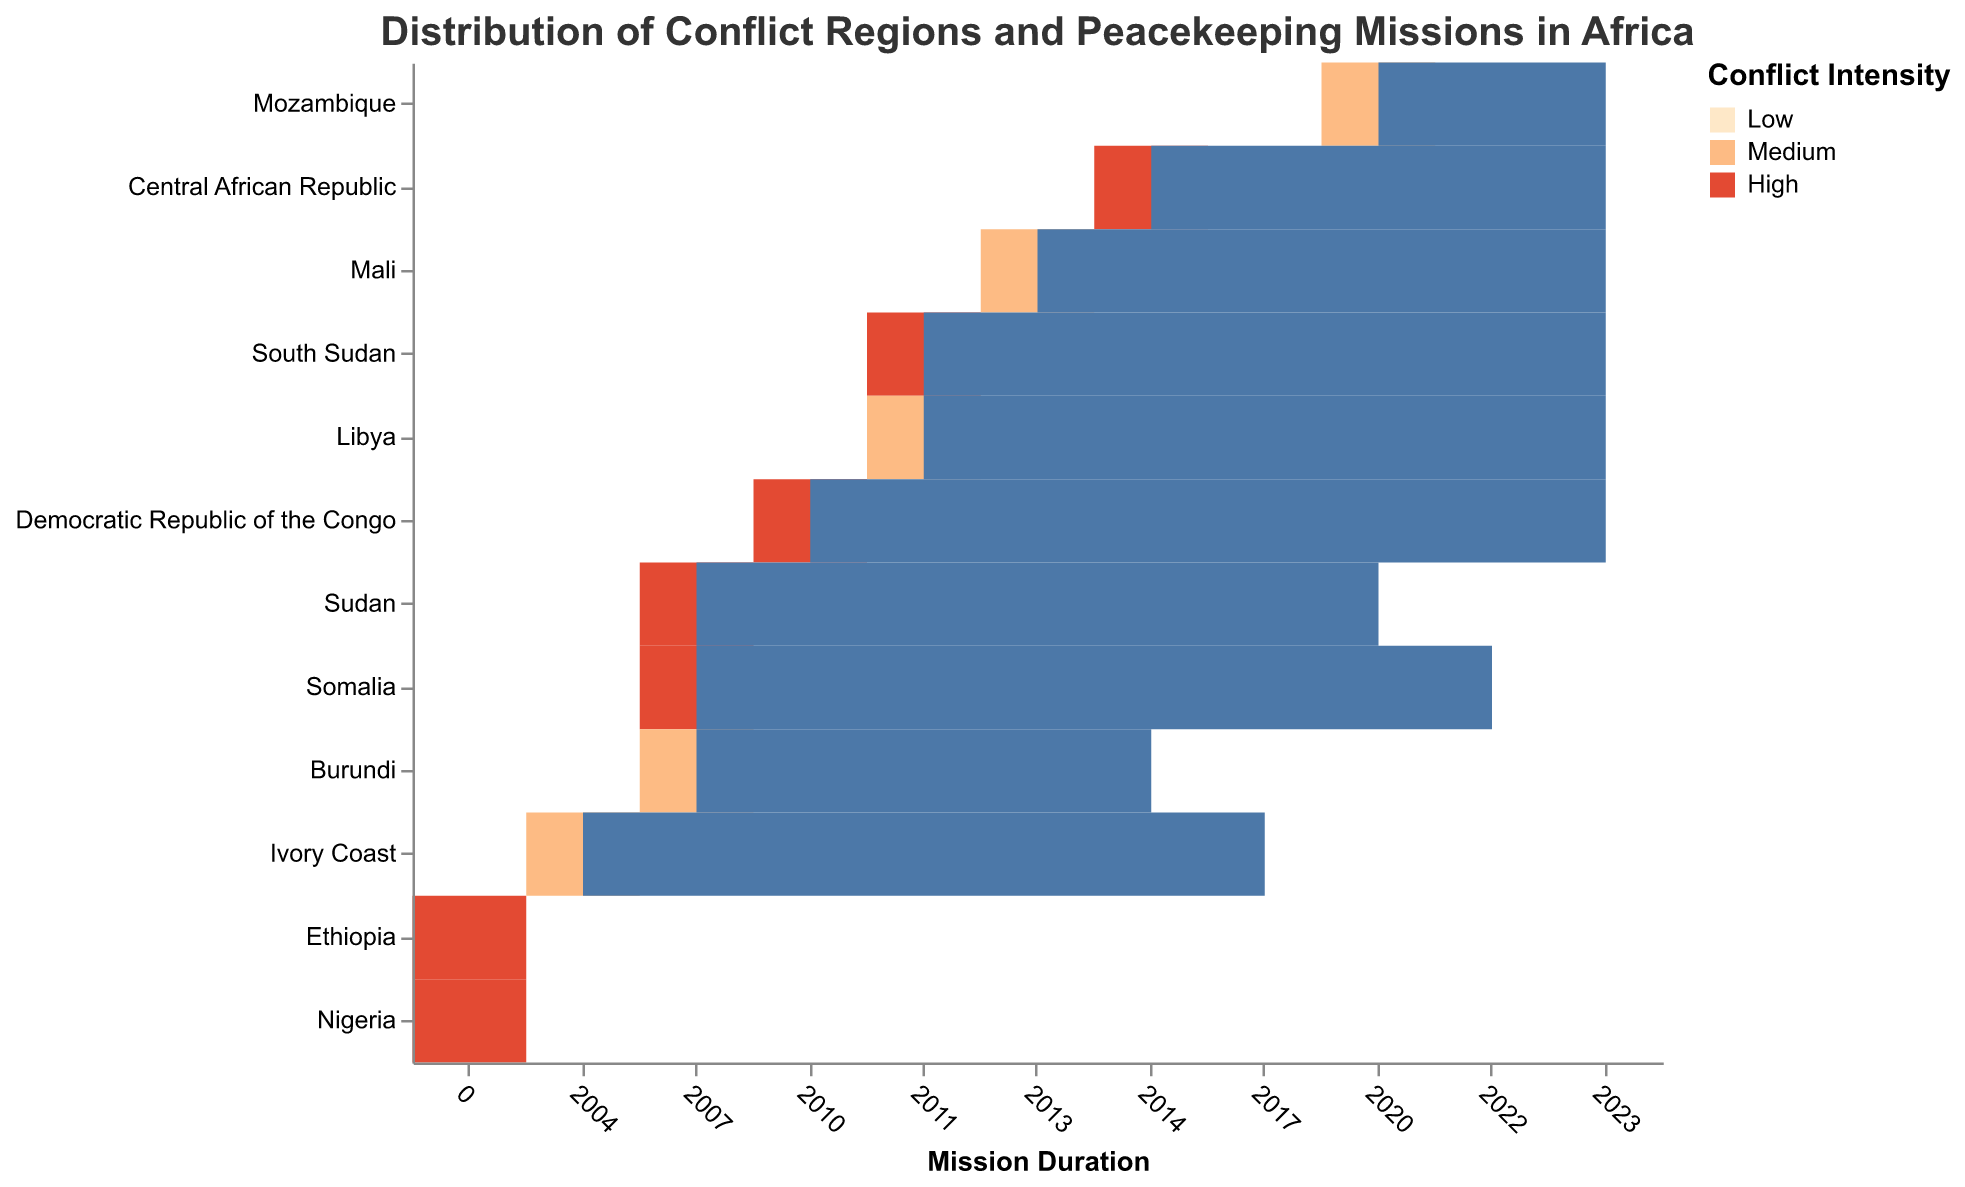What is the title of the heatmap? The title of the heatmap is written at the top of the figure.
Answer: Distribution of Conflict Regions and Peacekeeping Missions in Africa Which region has the highest conflict frequency? Look for the region with the darkest red color, which represents the highest frequency according to the color legend.
Answer: Mogadishu How many regions have 'High' conflict intensity? Count the number of regions that are colored red, as red indicates 'High' intensity.
Answer: 7 Identify the conflict regions that do not have any peacekeeping missions. Look for regions with 'None' under Peacekeeping Missions.
Answer: Tigray and Borno Which peacekeeping mission started the earliest? Check the start years in the x-axis and find the mission with the earliest year.
Answer: UNOCI (2004) Compare the conflict frequencies between Sudan's Darfur and South Sudan's Juba. Which one is higher? Check the conflict frequencies for Darfur and Juba from the tooltip or color intensity on the heatmap.
Answer: Darfur What is the average conflict frequency of 'Medium' intensity regions? Identify the regions with 'Medium' intensity, sum their conflict frequencies, and divide by the number of such regions.
Answer: (6 + 5 + 4 + 4 + 3) / 5 = 22 / 5 = 4.4 Which country has the longest ongoing peacekeeping mission? Find the country with a peacekeeping mission that started early and is still ongoing.
Answer: Democratic Republic of the Congo with MONUSCO Are there more regions with 'High' conflict intensity or 'Medium' conflict intensity? Count the number of regions for 'High' and 'Medium' intensity and compare.
Answer: High (7) 